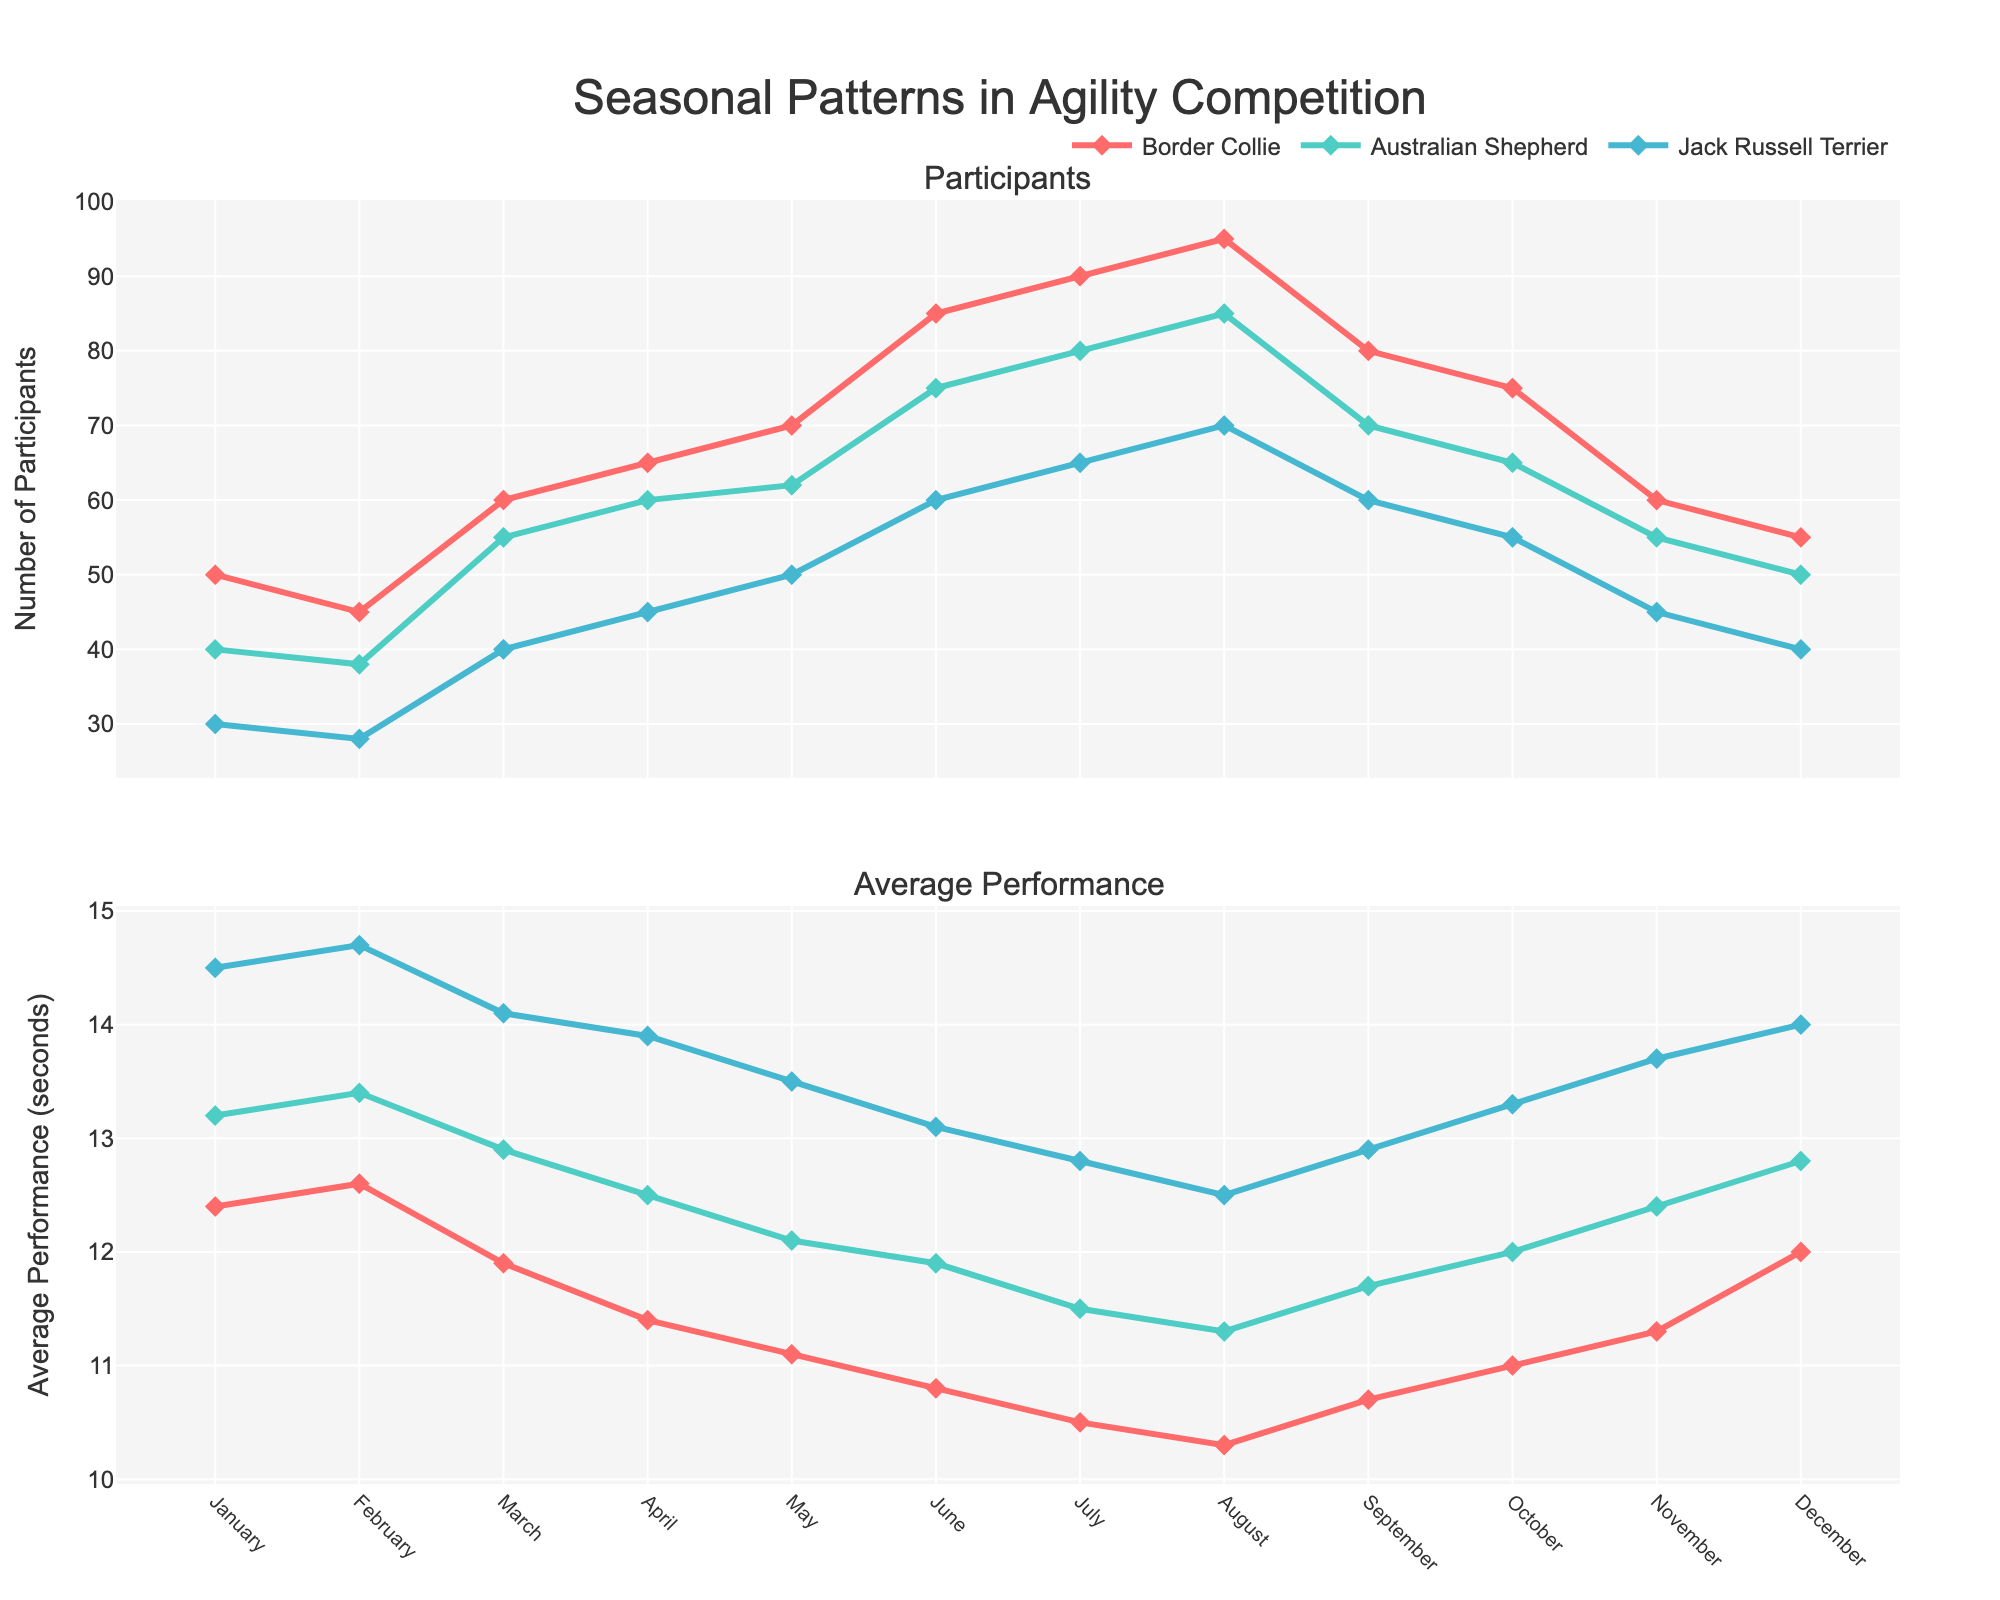What breed had the highest number of participants in July? By looking at the "Participants" subplot for the month of July, we see that the Border Collie had 90 participants while the Australian Shepherd had 80 and the Jack Russell Terrier had 65.
Answer: Border Collie How many participants were there in total for Border Collies in June and July? For June, the number of participants is 85, and for July, it's 90. Adding these together gives 85 + 90.
Answer: 175 What's the average performance for the Australian Shepherd in May and November? We note that in May, the average performance for the Australian Shepherd is 12.1 seconds, and in November, it's 12.4 seconds. The average of these two values is (12.1 + 12.4) / 2.
Answer: 12.25 seconds How does the performance of the Jack Russell Terrier in December compare to its performance in January? Jack Russell Terrier’s performance in December is 14 seconds, and in January, it is 14.5 seconds. December's performance is higher.
Answer: December is better Which breed shows the greatest improvement in performance from January to August? Looking at each breed's "Average Performance" subplot, Border Collies improved by about 2.1 seconds (from 12.4 to 10.3), Australian Shepherds by 1.9 seconds (from 13.2 to 11.3), and Jack Russell Terriers by about 2 seconds (from 14.5 to 12.5). Border Collies show the largest improvement.
Answer: Border Collie By how much did the number of participants for the Jack Russell Terrier increase from January to August? The number of participants for Jack Russell Terriers increased from 30 in January to 70 in August, which is an increase of 70 - 30.
Answer: 40 What is the trend in the average performance for Border Collies from June to September? Observing the "Average Performance" subplot for Border Collies, the performance slightly improves each month from June (10.8) to July (10.5), to August (10.3), to September (10.7). However, there is a slight decrease from August to September.
Answer: Improvement until September In which month did all breeds have their highest number of participants? Both from the first (Participants) subplot, we see that the highest participants for all breeds happen in August: Border Collies (95), Australian Shepherds (85), and Jack Russell Terriers (70).
Answer: August In which month did Border Collies show their best performance? On the "Average Performance" subplot, the lowest time for Border Collies is in August, with 10.3 seconds, indicating their best performance.
Answer: August 